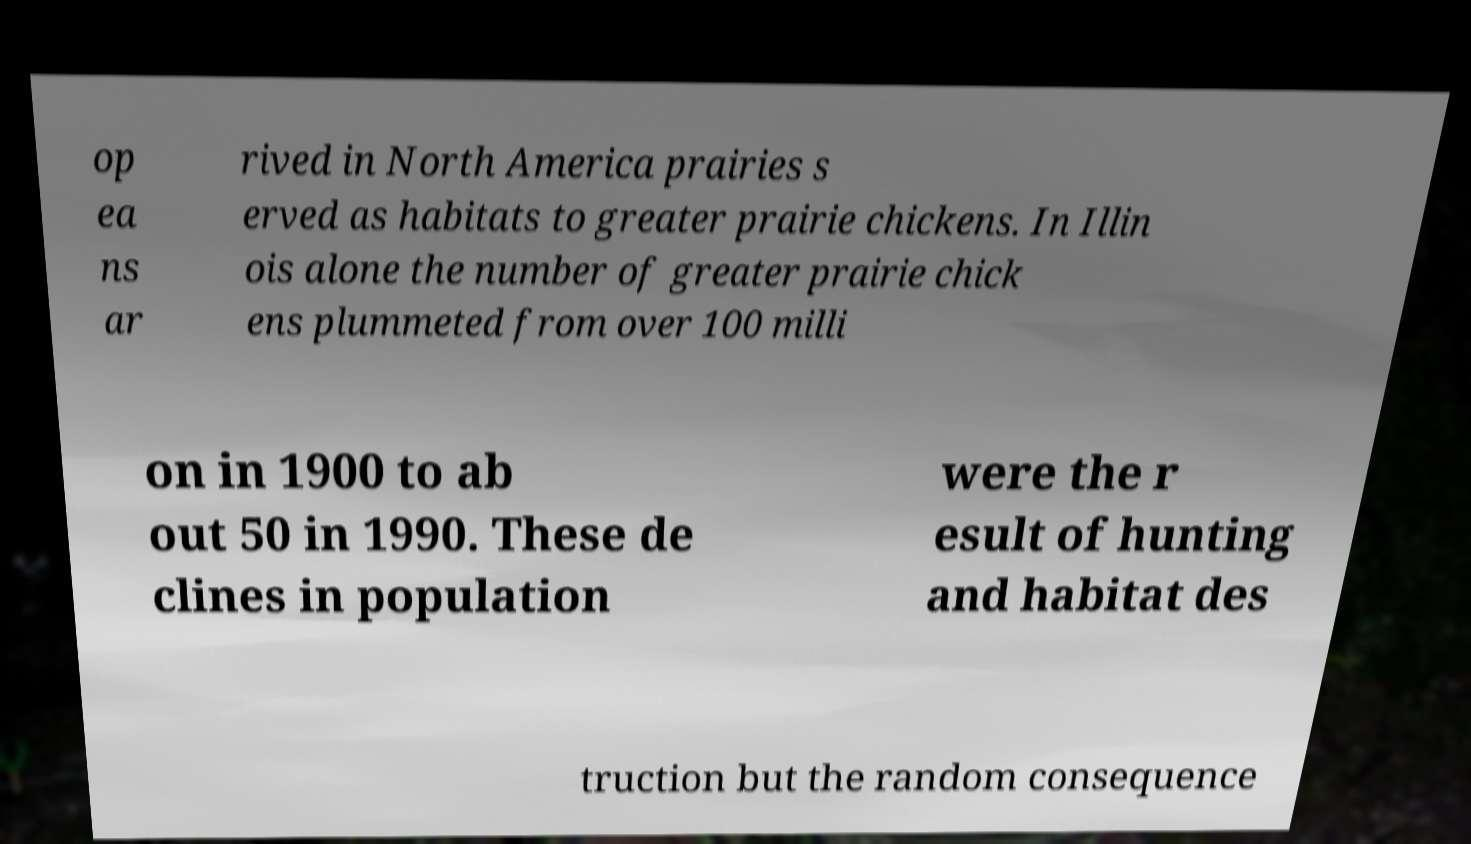Can you read and provide the text displayed in the image?This photo seems to have some interesting text. Can you extract and type it out for me? op ea ns ar rived in North America prairies s erved as habitats to greater prairie chickens. In Illin ois alone the number of greater prairie chick ens plummeted from over 100 milli on in 1900 to ab out 50 in 1990. These de clines in population were the r esult of hunting and habitat des truction but the random consequence 